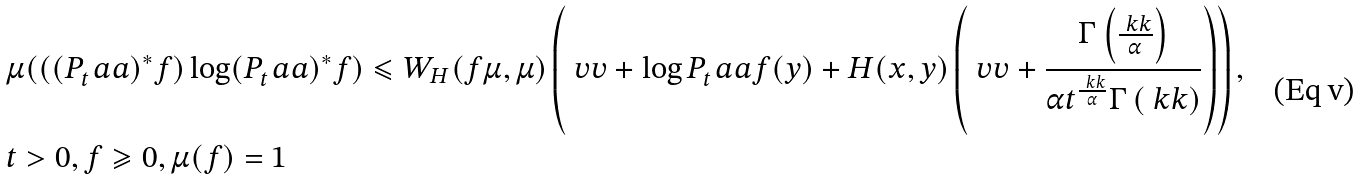Convert formula to latex. <formula><loc_0><loc_0><loc_500><loc_500>& \mu ( ( ( P _ { t } ^ { \ } a a ) ^ { * } f ) \log ( P _ { t } ^ { \ } a a ) ^ { * } f ) \leqslant W _ { H } ( f \mu , \mu ) \left ( \ v v + \log P _ { t } ^ { \ } a a f ( y ) + H ( x , y ) \left ( \ v v + \frac { \Gamma \left ( \frac { \ k k } { \alpha } \right ) } { \alpha t ^ { \frac { \ k k } { \alpha } } \Gamma \left ( \ k k \right ) } \right ) \right ) , \\ & t > 0 , f \geqslant 0 , \mu ( f ) = 1</formula> 